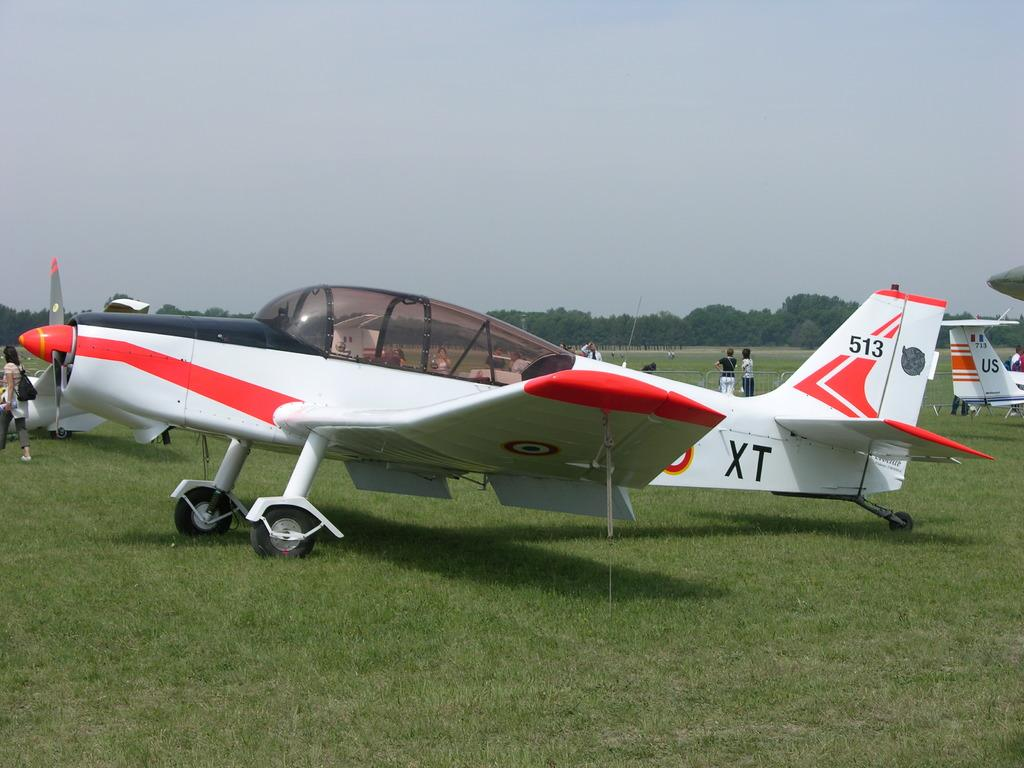<image>
Write a terse but informative summary of the picture. A small plane with the letters XT sits on a grass field. 